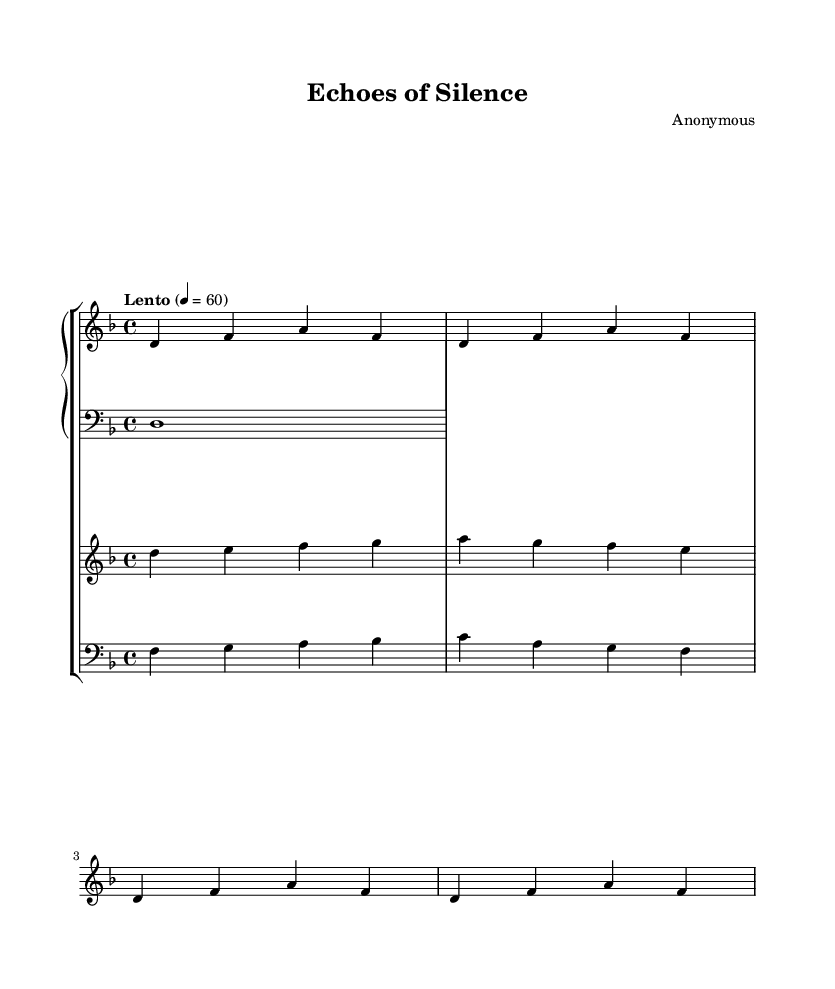What is the key signature of this music? The key signature is D minor, which contains one flat (B flat). The key signature is typically indicated at the beginning of the staff and can be confirmed by counting the flats shown.
Answer: D minor What is the time signature of this piece? The time signature is 4/4, which is denoted at the beginning of the music. It indicates that there are four beats in each measure and that a quarter note receives one beat.
Answer: 4/4 What is the tempo marking for this composition? The tempo marking is "Lento," which suggests a slow tempo. It is indicated at the start of the score and often guides the performer on the pace of the piece.
Answer: Lento How many measures does the piano right-hand part contain? The piano right-hand part consists of four measures as indicated by the repeated unfolding of the notes in the music notation, specifically repeated four times.
Answer: 4 What voice performs the main melody in the composition? The main melody is performed by the violin, as specified in the labeling of the staff. The violin part typically contains the prominent melodic line in this example.
Answer: Violin What is significant about the use of contrasting instruments in this piece? The contrasting instruments, including piano, violin, and cello, create a rich texture. The idea of using different timbres helps evoke the diverse emotional layers reflective of the historical context woven into the minimalist structure.
Answer: Diverse texture What emotional effect might the minimalist structure of this piece have when referencing historical themes? The minimalist structure creates a meditative and contemplative atmosphere, allowing the listener to reflect upon the subtle references to the historical trauma of the Spanish Inquisition interwoven in the music.
Answer: Contemplative atmosphere 